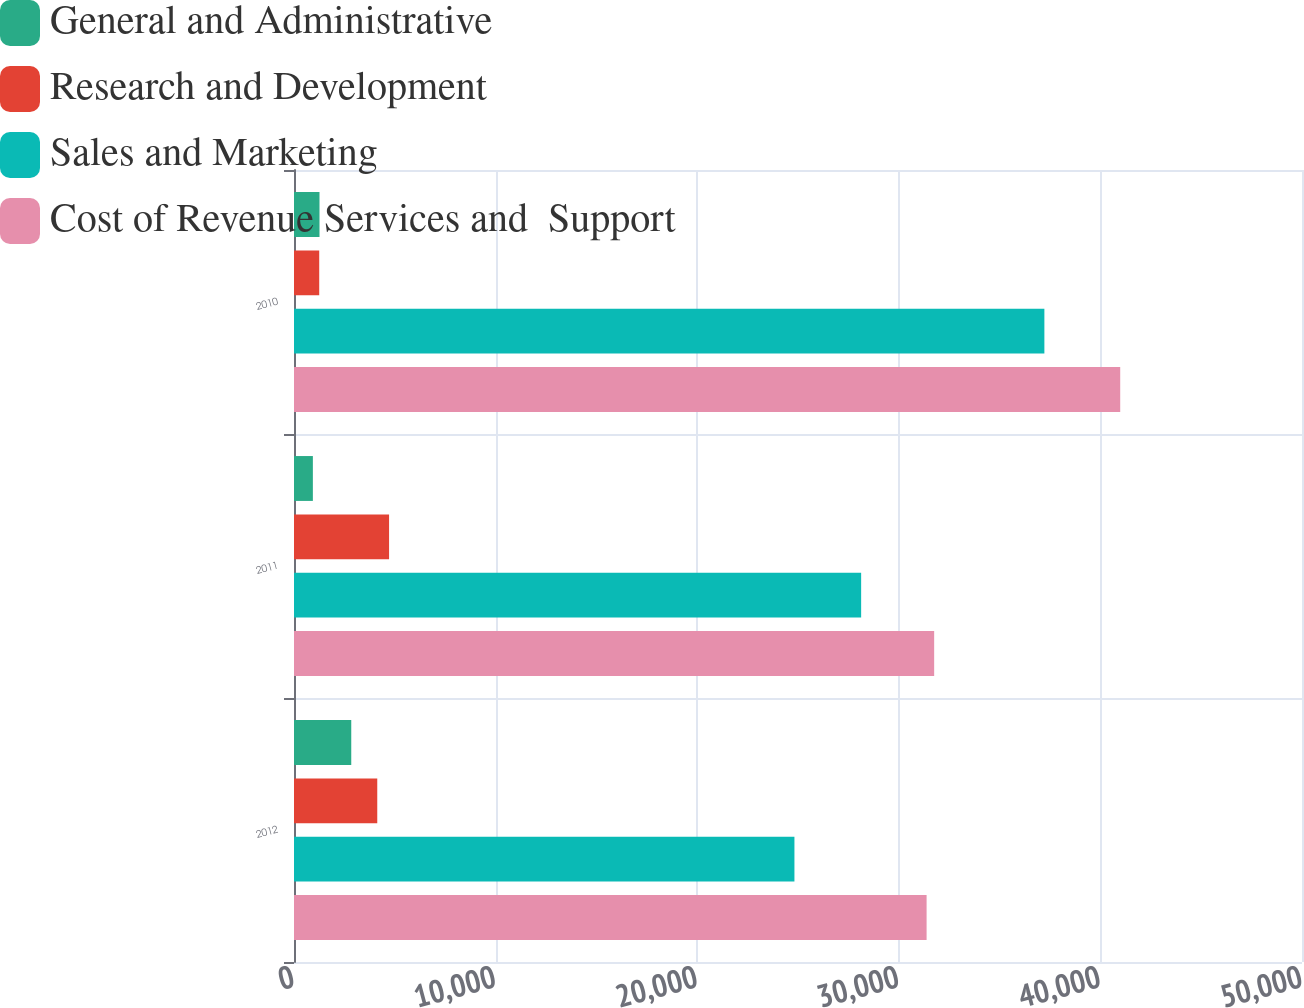<chart> <loc_0><loc_0><loc_500><loc_500><stacked_bar_chart><ecel><fcel>2012<fcel>2011<fcel>2010<nl><fcel>General and Administrative<fcel>2840<fcel>936<fcel>1265<nl><fcel>Research and Development<fcel>4130<fcel>4716<fcel>1251<nl><fcel>Sales and Marketing<fcel>24823<fcel>28132<fcel>37221<nl><fcel>Cost of Revenue Services and  Support<fcel>31379<fcel>31754<fcel>40983<nl></chart> 